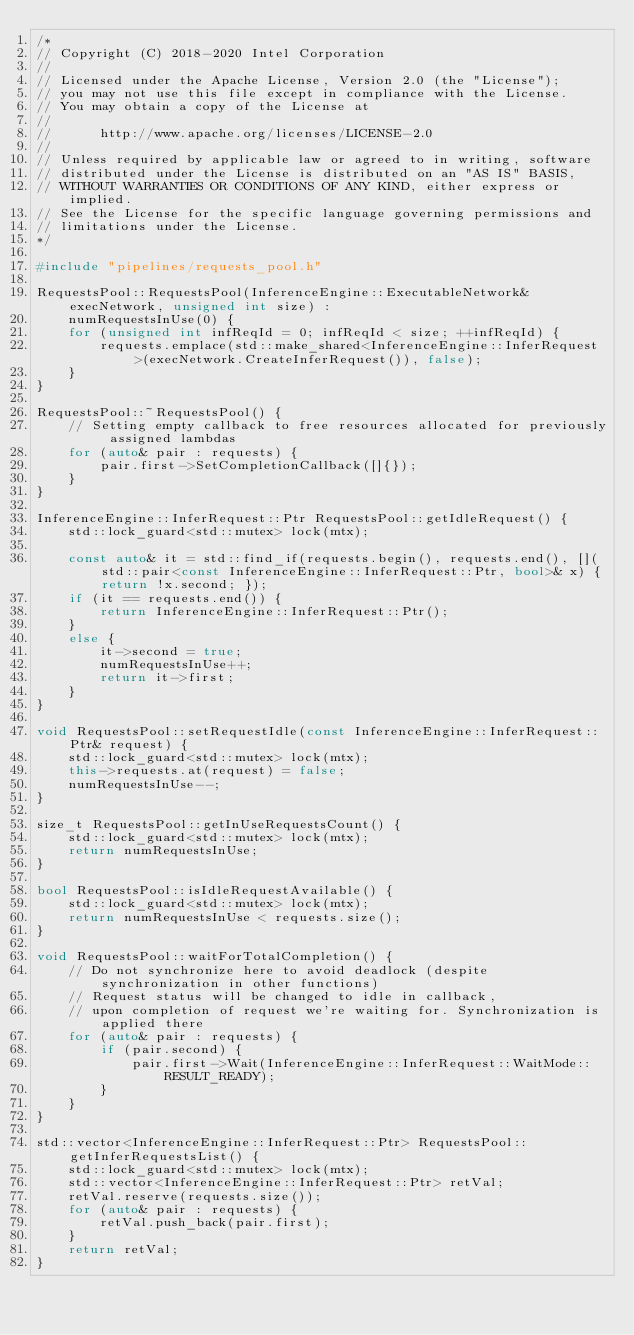Convert code to text. <code><loc_0><loc_0><loc_500><loc_500><_C++_>/*
// Copyright (C) 2018-2020 Intel Corporation
//
// Licensed under the Apache License, Version 2.0 (the "License");
// you may not use this file except in compliance with the License.
// You may obtain a copy of the License at
//
//      http://www.apache.org/licenses/LICENSE-2.0
//
// Unless required by applicable law or agreed to in writing, software
// distributed under the License is distributed on an "AS IS" BASIS,
// WITHOUT WARRANTIES OR CONDITIONS OF ANY KIND, either express or implied.
// See the License for the specific language governing permissions and
// limitations under the License.
*/

#include "pipelines/requests_pool.h"

RequestsPool::RequestsPool(InferenceEngine::ExecutableNetwork& execNetwork, unsigned int size) :
    numRequestsInUse(0) {
    for (unsigned int infReqId = 0; infReqId < size; ++infReqId) {
        requests.emplace(std::make_shared<InferenceEngine::InferRequest>(execNetwork.CreateInferRequest()), false);
    }
}

RequestsPool::~RequestsPool() {
    // Setting empty callback to free resources allocated for previously assigned lambdas
    for (auto& pair : requests) {
        pair.first->SetCompletionCallback([]{});
    }
}

InferenceEngine::InferRequest::Ptr RequestsPool::getIdleRequest() {
    std::lock_guard<std::mutex> lock(mtx);

    const auto& it = std::find_if(requests.begin(), requests.end(), [](std::pair<const InferenceEngine::InferRequest::Ptr, bool>& x) {return !x.second; });
    if (it == requests.end()) {
        return InferenceEngine::InferRequest::Ptr();
    }
    else {
        it->second = true;
        numRequestsInUse++;
        return it->first;
    }
}

void RequestsPool::setRequestIdle(const InferenceEngine::InferRequest::Ptr& request) {
    std::lock_guard<std::mutex> lock(mtx);
    this->requests.at(request) = false;
    numRequestsInUse--;
}

size_t RequestsPool::getInUseRequestsCount() {
    std::lock_guard<std::mutex> lock(mtx);
    return numRequestsInUse;
}

bool RequestsPool::isIdleRequestAvailable() {
    std::lock_guard<std::mutex> lock(mtx);
    return numRequestsInUse < requests.size();
}

void RequestsPool::waitForTotalCompletion() {
    // Do not synchronize here to avoid deadlock (despite synchronization in other functions)
    // Request status will be changed to idle in callback,
    // upon completion of request we're waiting for. Synchronization is applied there
    for (auto& pair : requests) {
        if (pair.second) {
            pair.first->Wait(InferenceEngine::InferRequest::WaitMode::RESULT_READY);
        }
    }
}

std::vector<InferenceEngine::InferRequest::Ptr> RequestsPool::getInferRequestsList() {
    std::lock_guard<std::mutex> lock(mtx);
    std::vector<InferenceEngine::InferRequest::Ptr> retVal;
    retVal.reserve(requests.size());
    for (auto& pair : requests) {
        retVal.push_back(pair.first);
    }
    return retVal;
}
</code> 